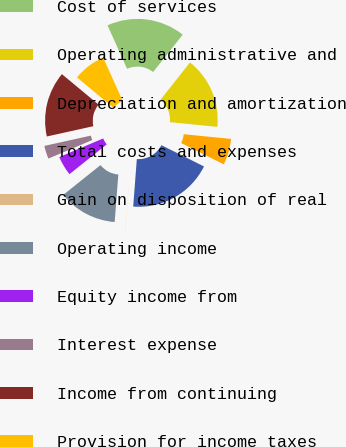<chart> <loc_0><loc_0><loc_500><loc_500><pie_chart><fcel>Cost of services<fcel>Operating administrative and<fcel>Depreciation and amortization<fcel>Total costs and expenses<fcel>Gain on disposition of real<fcel>Operating income<fcel>Equity income from<fcel>Interest expense<fcel>Income from continuing<fcel>Provision for income taxes<nl><fcel>17.38%<fcel>15.93%<fcel>5.8%<fcel>18.83%<fcel>0.02%<fcel>13.04%<fcel>4.36%<fcel>2.91%<fcel>14.49%<fcel>7.25%<nl></chart> 